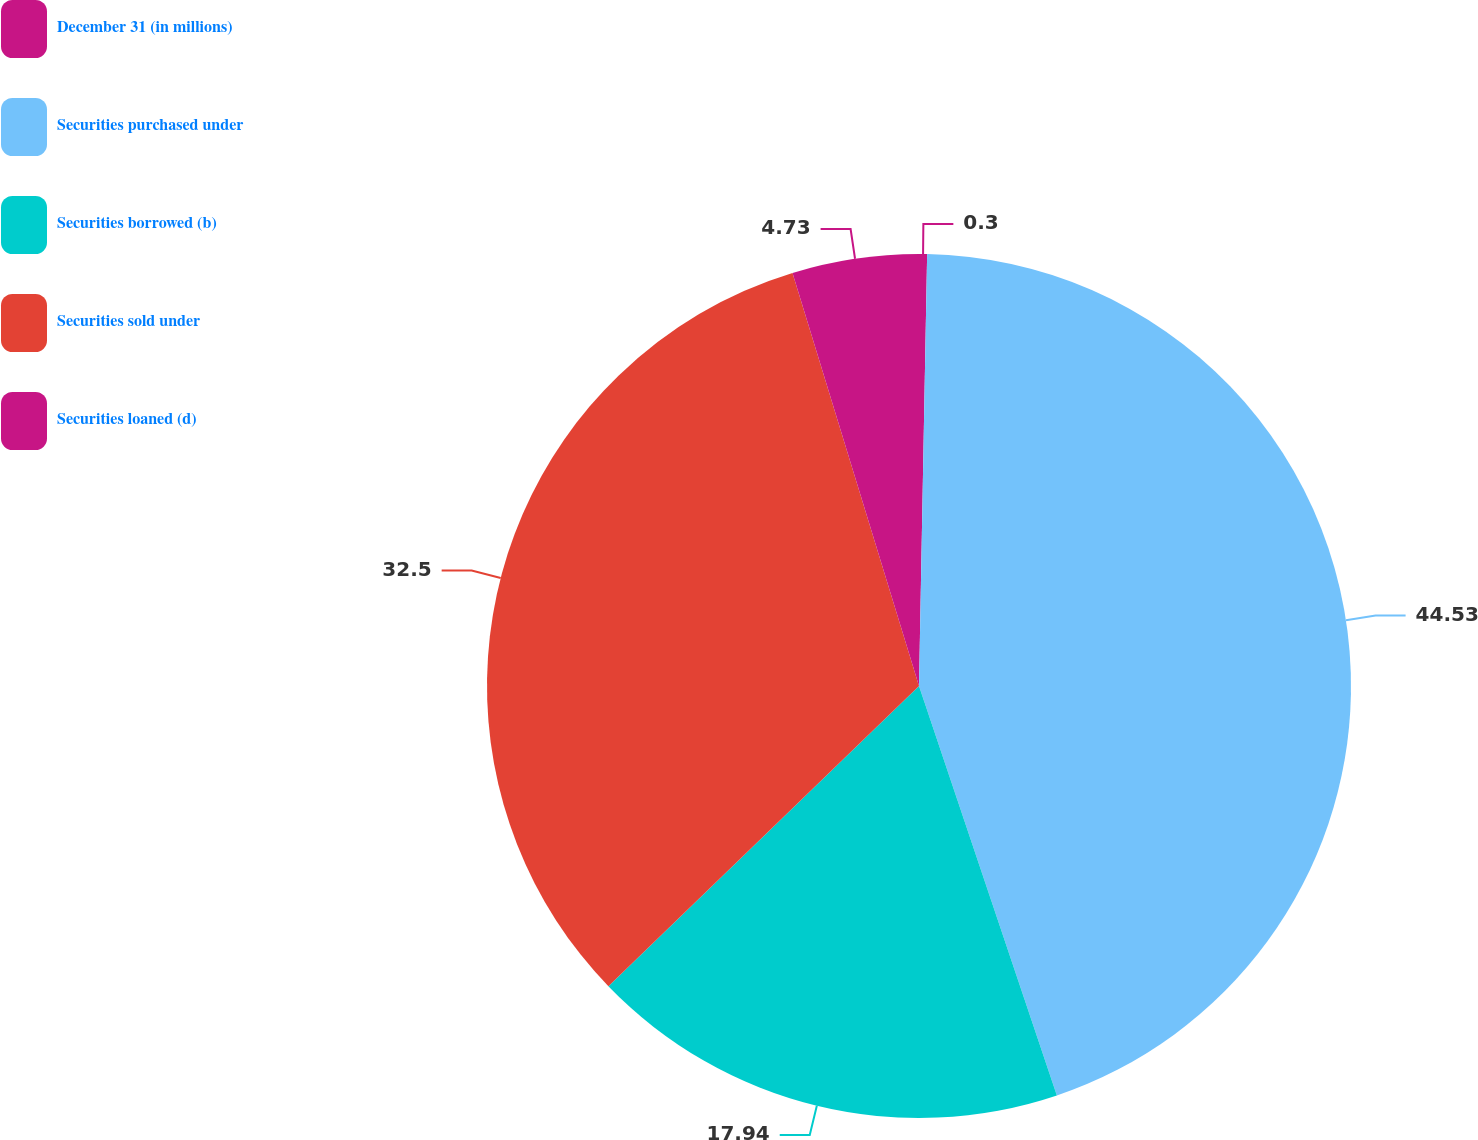<chart> <loc_0><loc_0><loc_500><loc_500><pie_chart><fcel>December 31 (in millions)<fcel>Securities purchased under<fcel>Securities borrowed (b)<fcel>Securities sold under<fcel>Securities loaned (d)<nl><fcel>0.3%<fcel>44.53%<fcel>17.94%<fcel>32.5%<fcel>4.73%<nl></chart> 